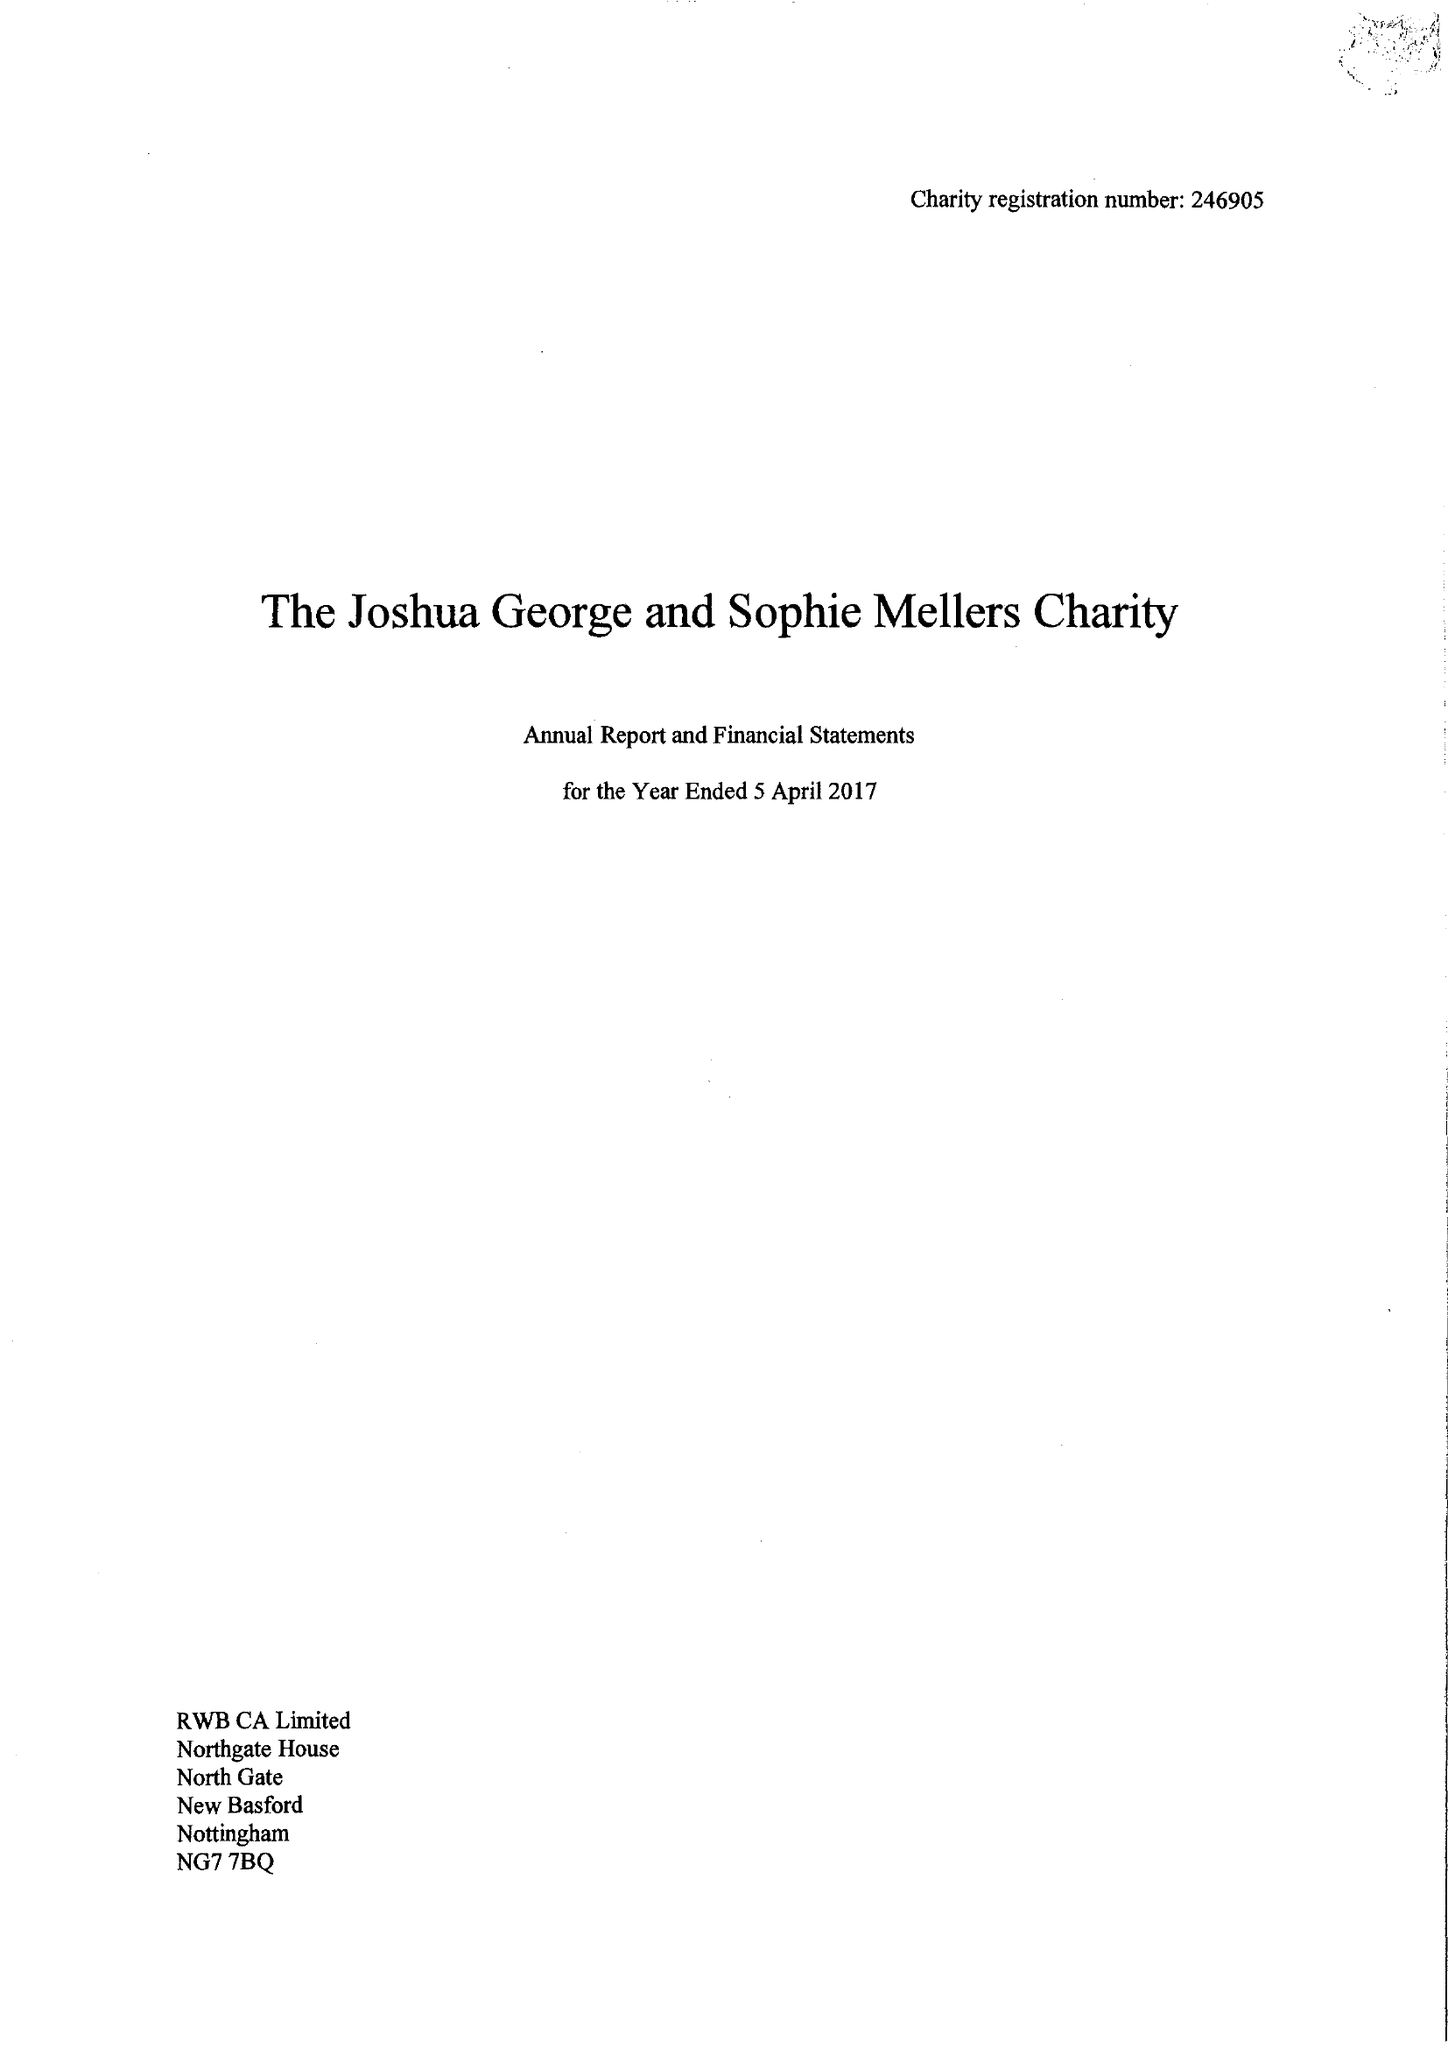What is the value for the address__street_line?
Answer the question using a single word or phrase. 80 MOUNT STREET 